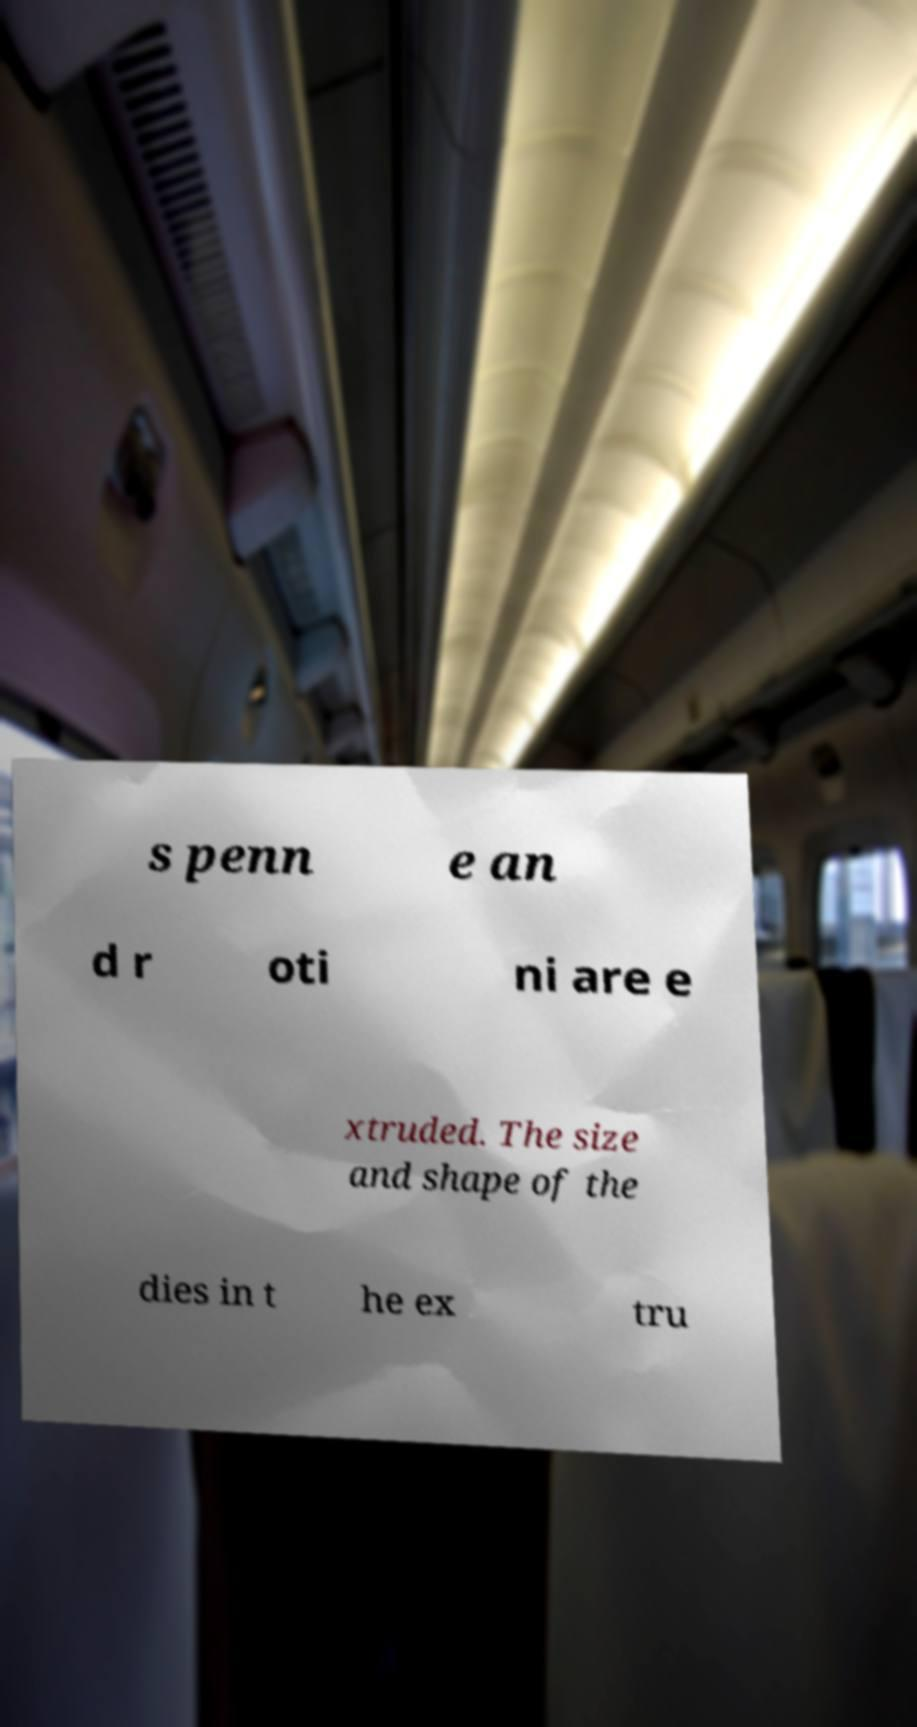Can you read and provide the text displayed in the image?This photo seems to have some interesting text. Can you extract and type it out for me? s penn e an d r oti ni are e xtruded. The size and shape of the dies in t he ex tru 